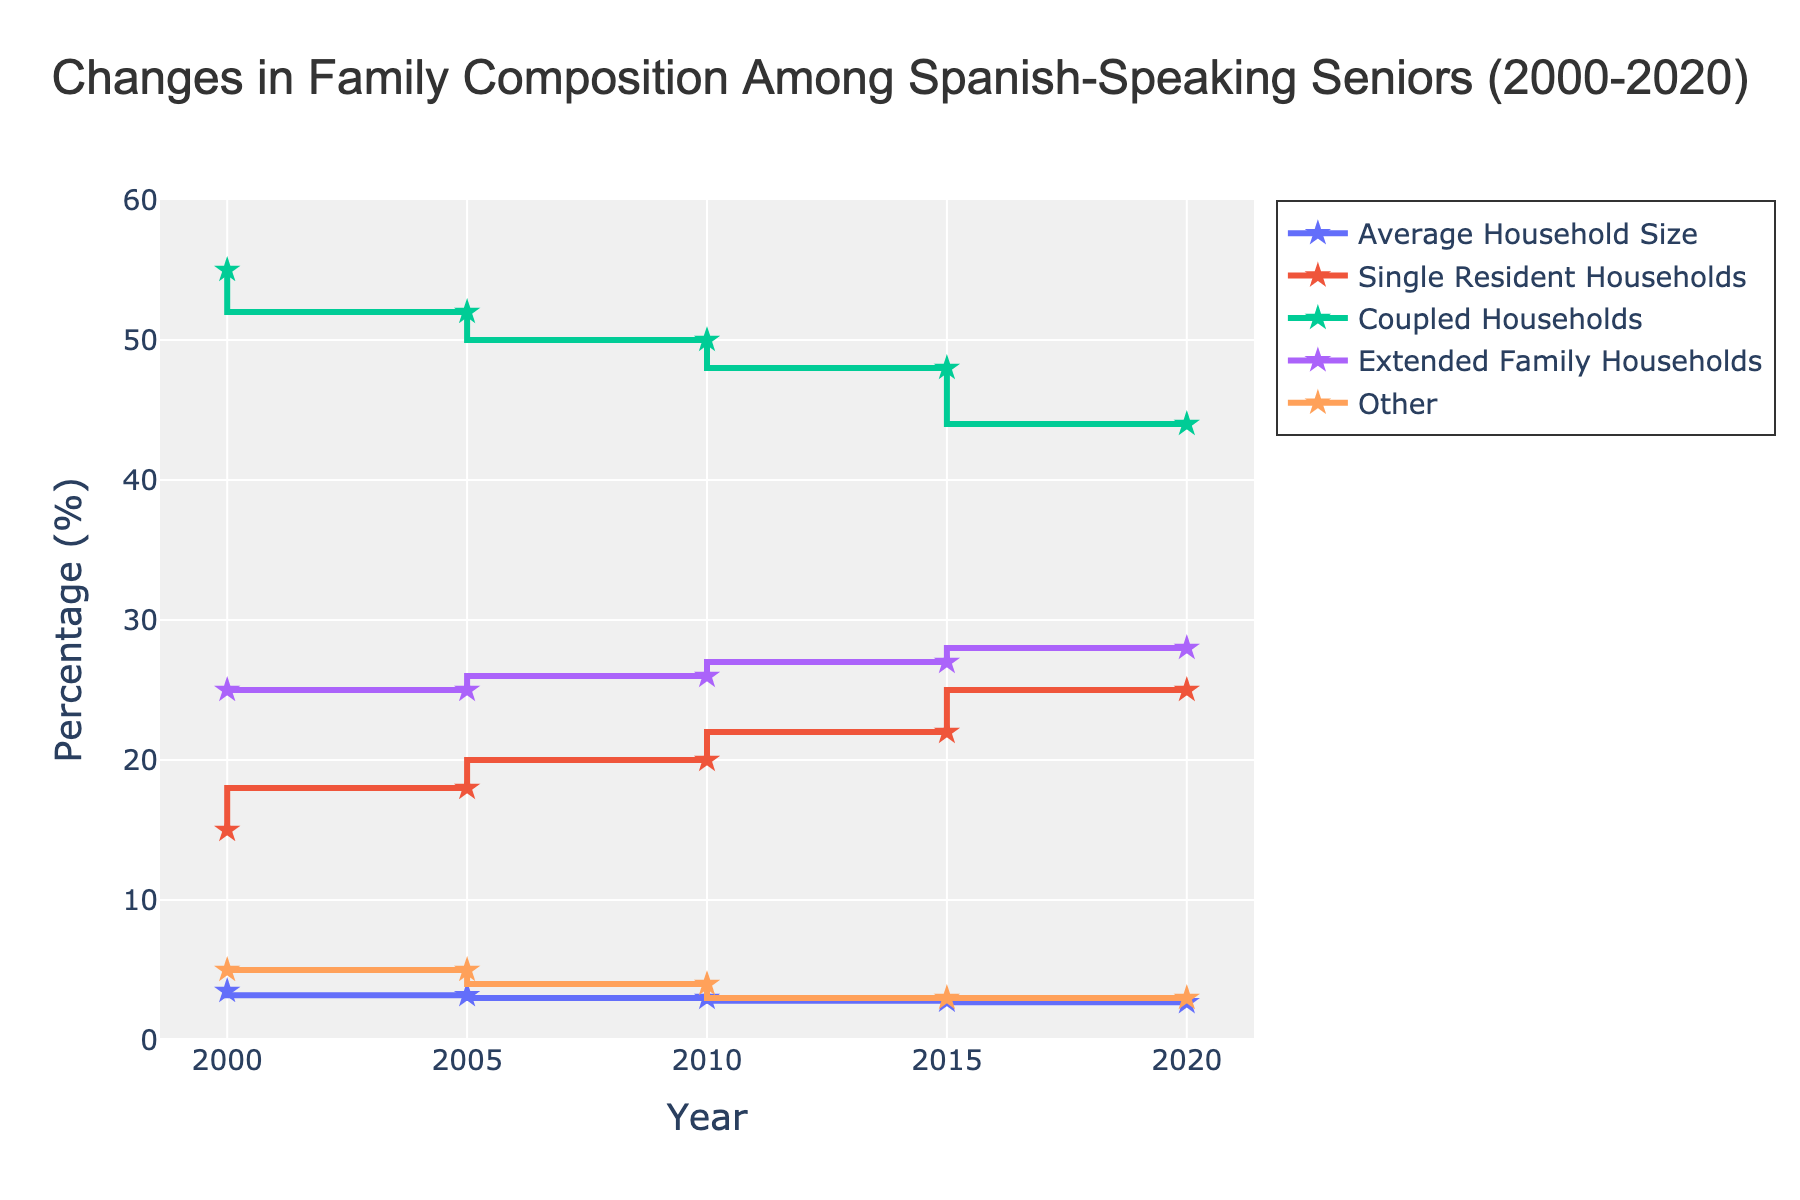What's the average household size in 2020? The plot indicates the values of the average household size across different years, including 2020. Simply looking at the 'Average Household Size' data for 2020 reveals the value directly.
Answer: 2.7 What was the percentage of coupled households in 2010, and how does it compare to that in 2020? Check the 'Coupled Households' line for both 2010 and 2020. In 2010, it is 50%, and in 2020, it is 44%. The difference can be found by subtracting the two percentages.
Answer: In 2010, it was 50%. In 2020, it was 44%. So, it decreased by 6% In which year did single resident households see the most significant increase in percentage? Look at the 'Single Resident Households' line and determine the year-to-year changes. Compare the differences: 2000 to 2005 (15% to 18%), 2005 to 2010 (18% to 20%), 2010 to 2015 (20% to 22%), and 2015 to 2020 (22% to 25%). The greatest increase occurred between 2015 and 2020.
Answer: Between 2015 and 2020, increasing by 3% What is the relationship between average household size and extended family households over the years? Observe the trends of both 'Average Household Size' and 'Extended Family Households'. As the average household size decreases from 3.5 in 2000 to 2.7 in 2020, the percentage of extended family households increases from 25% in 2000 to 28% in 2020.
Answer: An inverse relationship; as household size decreases, extended family households increase Which household type remained most stable over the 20 years, and how can you tell? Examine the variability in the lines for each household type. The 'Extended Family Households' and 'Other' lines show less variation. However, 'Other' is the most stable, hovering around 4-5%.
Answer: 'Other' households, as the percentage stays around 4-5% How many percentage points did single resident households increase from 2000 to 2020? Look at the 'Single Resident Households' percentages for both years. 2000 was 15%, and 2020 was 25%. Subtract the former from the latter to get the change.
Answer: 10 percentage points In which year did coupled households see the most significant drop, and by how much? Compare the percentage values yearly for coupled households, noting the differences: 2000 to 2005 (55% to 52%), 2005 to 2010 (52% to 50%), 2010 to 2015 (50% to 48%), and 2015 to 2020 (48% to 44%). The sharpest decline is from 2015 to 2020, a drop of 4%.
Answer: In 2020, by 4 percentage points from 2015 What trend can be observed about the 'Other' category from 2000 to 2020? The 'Other' category line is relatively flat with minor fluctuations, starting and ending at about the same percentage (5% in 2000 and 3% in 2020).
Answer: It remains mostly stable with slight fluctuations, starting at 5% and ending at 3% What's the total percentage of coupled and single resident households in 2015? For 2015, add the percentage values of 'Coupled Households' (48%) and 'Single Resident Households' (22%).
Answer: 70% What is the title of the plot? The title is the textual information provided at the top center of the plot.
Answer: "Changes in Family Composition Among Spanish-Speaking Seniors (2000-2020)" 